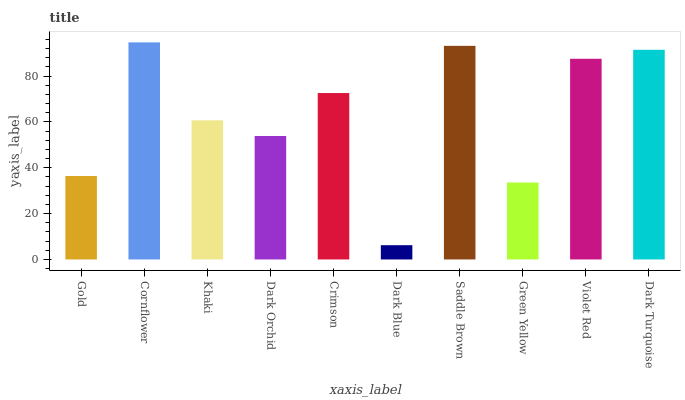Is Dark Blue the minimum?
Answer yes or no. Yes. Is Cornflower the maximum?
Answer yes or no. Yes. Is Khaki the minimum?
Answer yes or no. No. Is Khaki the maximum?
Answer yes or no. No. Is Cornflower greater than Khaki?
Answer yes or no. Yes. Is Khaki less than Cornflower?
Answer yes or no. Yes. Is Khaki greater than Cornflower?
Answer yes or no. No. Is Cornflower less than Khaki?
Answer yes or no. No. Is Crimson the high median?
Answer yes or no. Yes. Is Khaki the low median?
Answer yes or no. Yes. Is Green Yellow the high median?
Answer yes or no. No. Is Violet Red the low median?
Answer yes or no. No. 